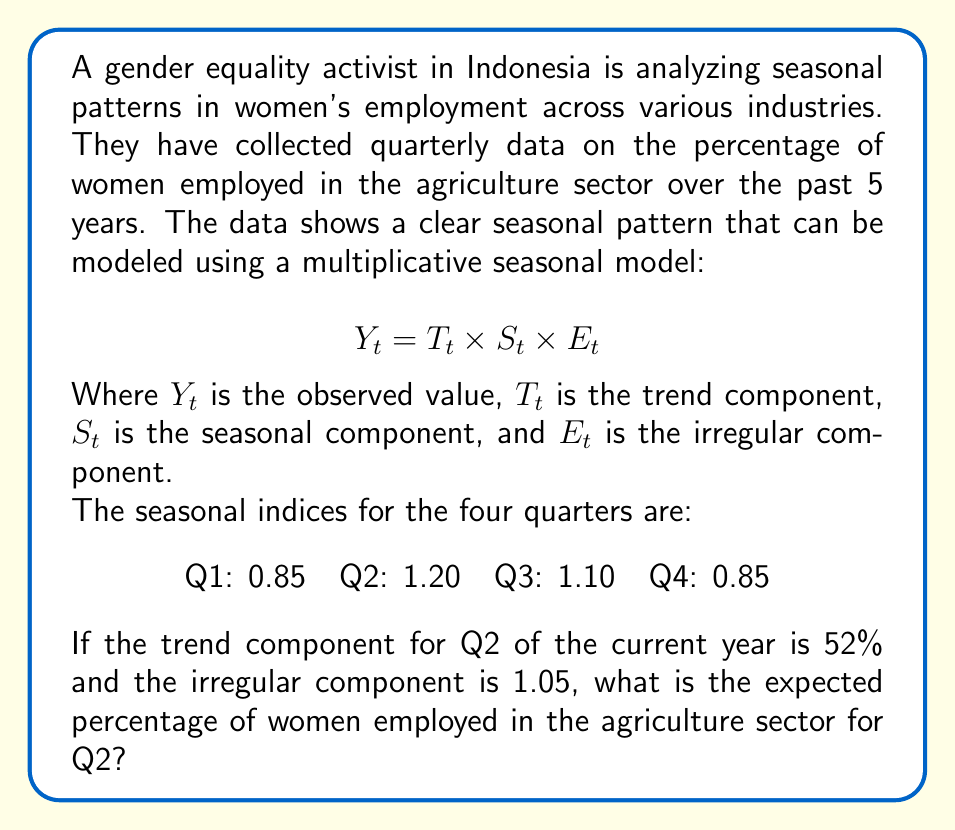Help me with this question. To solve this problem, we need to use the multiplicative seasonal model formula and the given information. Let's break it down step by step:

1. The multiplicative seasonal model is given by:
   $$Y_t = T_t \times S_t \times E_t$$

2. We are given the following information:
   - $T_t$ (trend component for Q2) = 52%
   - $S_t$ (seasonal index for Q2) = 1.20
   - $E_t$ (irregular component) = 1.05

3. To calculate $Y_t$, we simply multiply these components:
   $$Y_t = 0.52 \times 1.20 \times 1.05$$

4. Let's perform the calculation:
   $$Y_t = 0.52 \times 1.20 \times 1.05 = 0.6552$$

5. Convert the result to a percentage:
   $$Y_t = 0.6552 \times 100\% = 65.52\%$$

Therefore, the expected percentage of women employed in the agriculture sector for Q2 of the current year is 65.52%.

This result shows how the seasonal factor (1.20 for Q2) increases the employment percentage above the trend level, while the irregular component (1.05) adds a slight additional increase.
Answer: 65.52% 